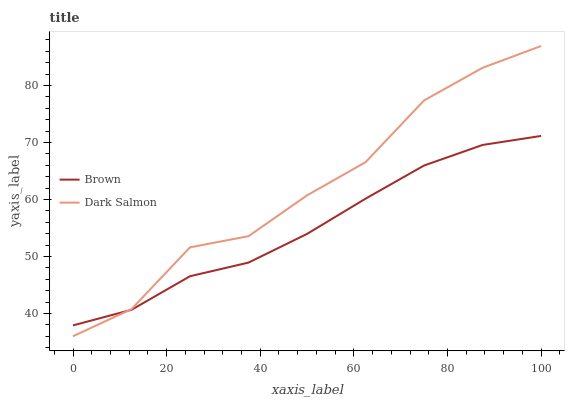Does Brown have the minimum area under the curve?
Answer yes or no. Yes. Does Dark Salmon have the maximum area under the curve?
Answer yes or no. Yes. Does Dark Salmon have the minimum area under the curve?
Answer yes or no. No. Is Brown the smoothest?
Answer yes or no. Yes. Is Dark Salmon the roughest?
Answer yes or no. Yes. Is Dark Salmon the smoothest?
Answer yes or no. No. Does Dark Salmon have the highest value?
Answer yes or no. Yes. Does Dark Salmon intersect Brown?
Answer yes or no. Yes. Is Dark Salmon less than Brown?
Answer yes or no. No. Is Dark Salmon greater than Brown?
Answer yes or no. No. 